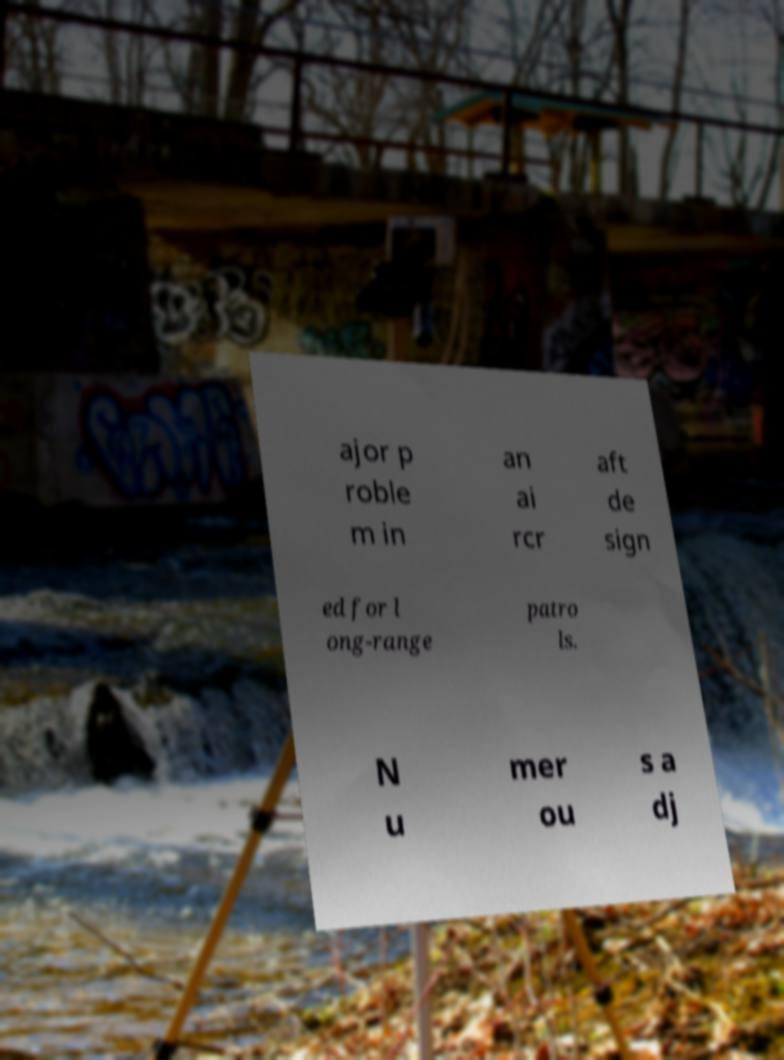Could you extract and type out the text from this image? ajor p roble m in an ai rcr aft de sign ed for l ong-range patro ls. N u mer ou s a dj 